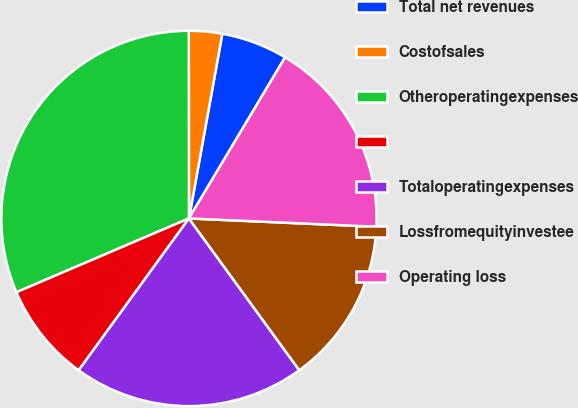<chart> <loc_0><loc_0><loc_500><loc_500><pie_chart><fcel>Total net revenues<fcel>Costofsales<fcel>Otheroperatingexpenses<fcel>Unnamed: 3<fcel>Totaloperatingexpenses<fcel>Lossfromequityinvestee<fcel>Operating loss<nl><fcel>5.72%<fcel>2.86%<fcel>31.42%<fcel>8.57%<fcel>20.0%<fcel>14.29%<fcel>17.14%<nl></chart> 